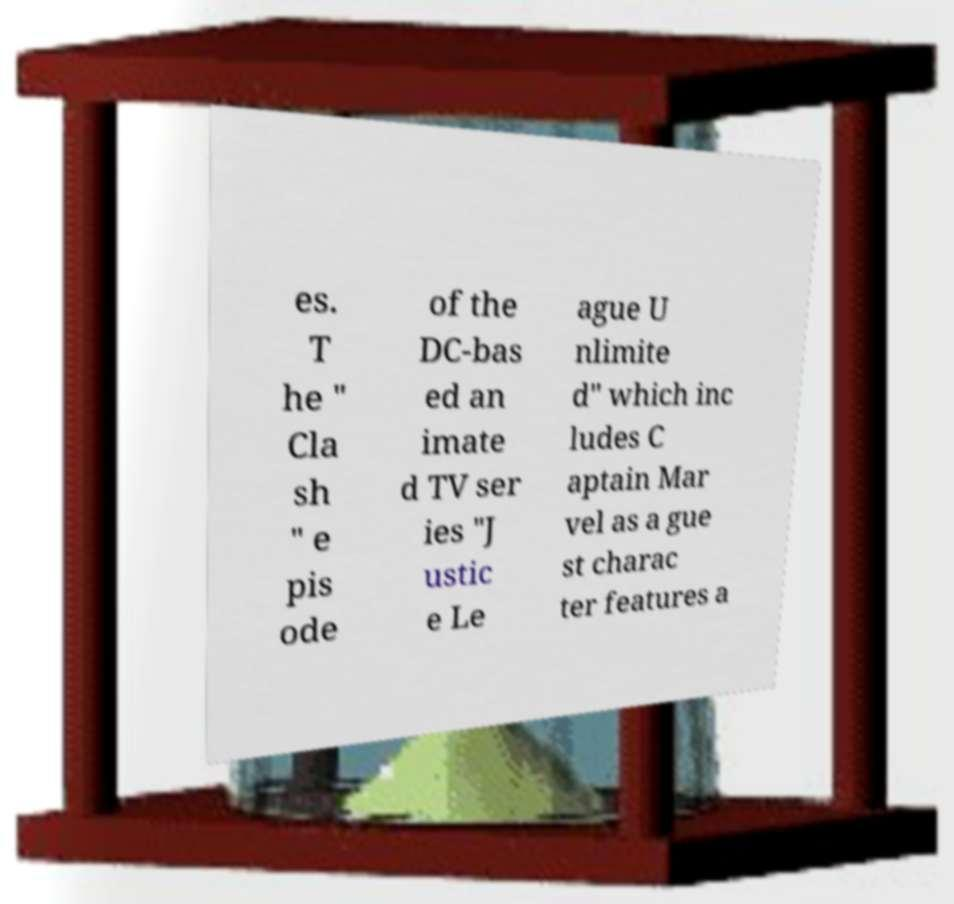Please read and relay the text visible in this image. What does it say? es. T he " Cla sh " e pis ode of the DC-bas ed an imate d TV ser ies "J ustic e Le ague U nlimite d" which inc ludes C aptain Mar vel as a gue st charac ter features a 